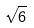Convert formula to latex. <formula><loc_0><loc_0><loc_500><loc_500>\sqrt { 6 }</formula> 